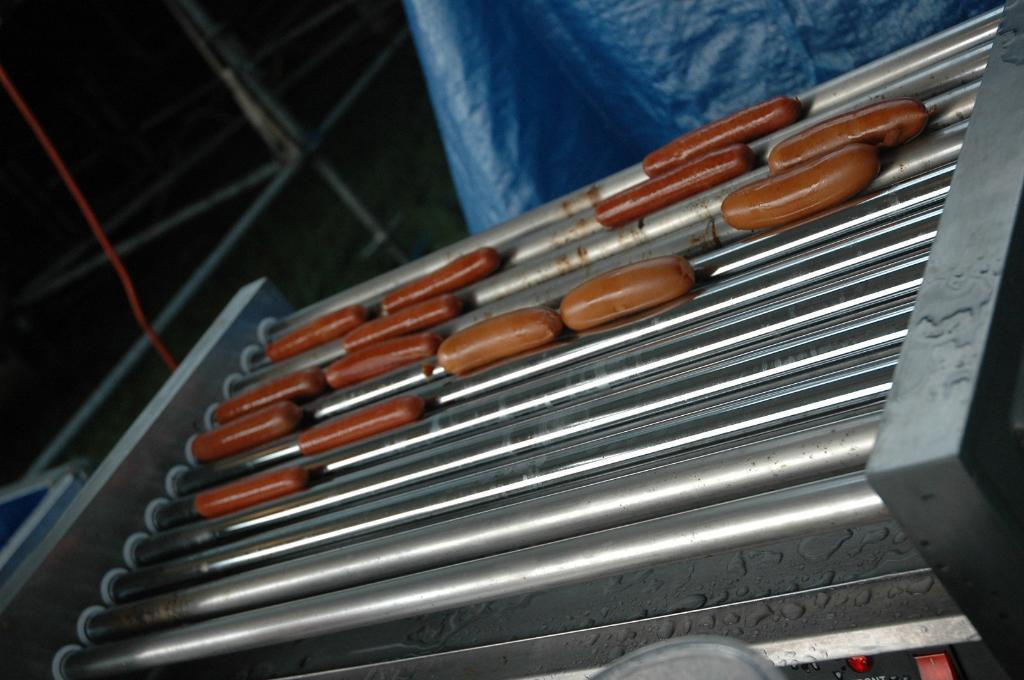What is the main subject in the center of the image? There is food in the center of the image. What can be seen in the background of the image? There is a blue sheet and a stand in the background of the image. Is there any quicksand visible in the image? No, there is no quicksand present in the image. What type of sponge can be seen in the image? There is no sponge present in the image. 